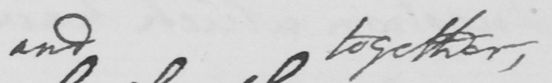Please provide the text content of this handwritten line. and together , 